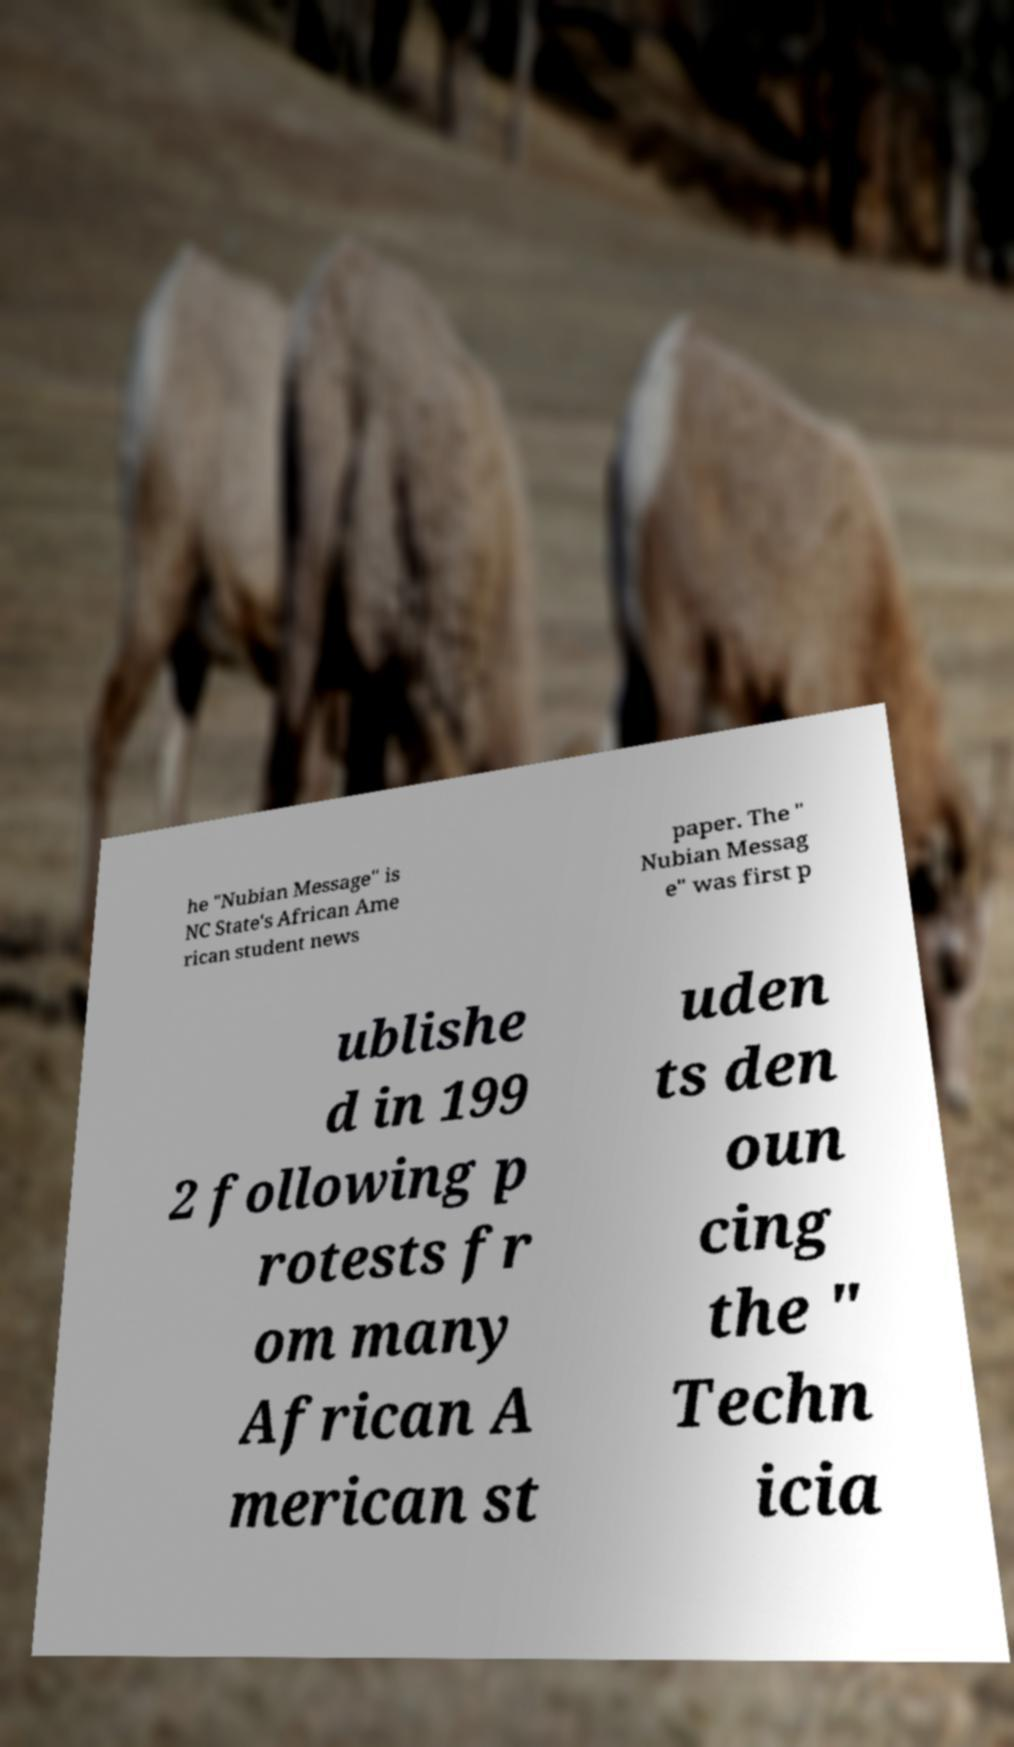I need the written content from this picture converted into text. Can you do that? he "Nubian Message" is NC State's African Ame rican student news paper. The " Nubian Messag e" was first p ublishe d in 199 2 following p rotests fr om many African A merican st uden ts den oun cing the " Techn icia 